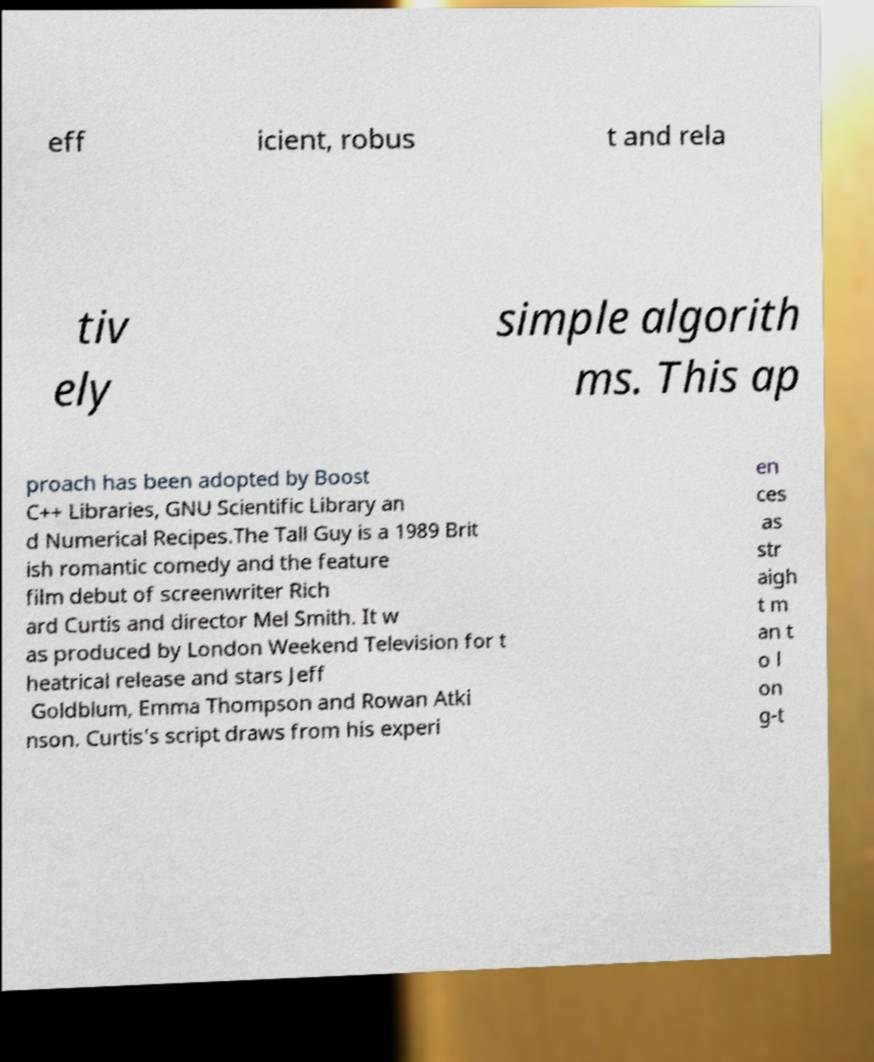Please read and relay the text visible in this image. What does it say? eff icient, robus t and rela tiv ely simple algorith ms. This ap proach has been adopted by Boost C++ Libraries, GNU Scientific Library an d Numerical Recipes.The Tall Guy is a 1989 Brit ish romantic comedy and the feature film debut of screenwriter Rich ard Curtis and director Mel Smith. It w as produced by London Weekend Television for t heatrical release and stars Jeff Goldblum, Emma Thompson and Rowan Atki nson. Curtis's script draws from his experi en ces as str aigh t m an t o l on g-t 